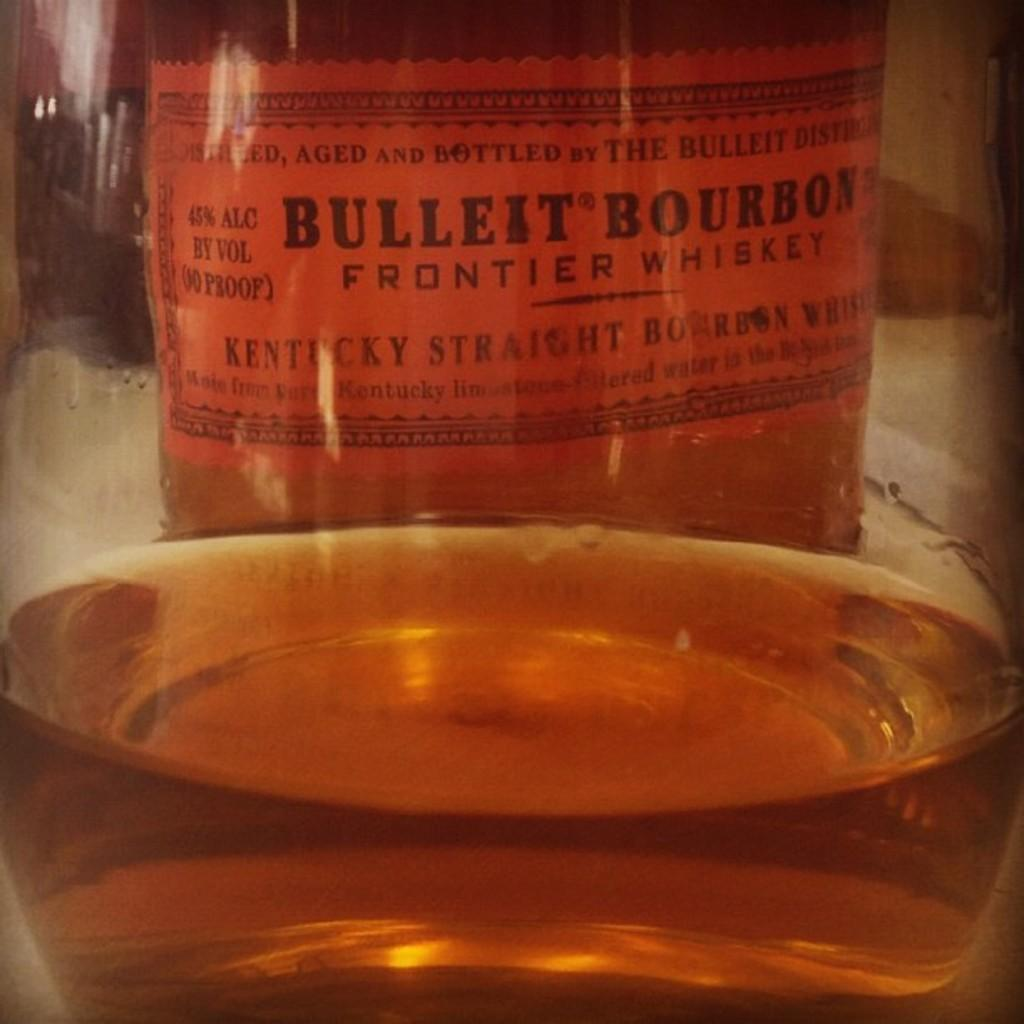<image>
Create a compact narrative representing the image presented. A glass of bullleit bourbon sitting in front of the bourbons original bottle. 